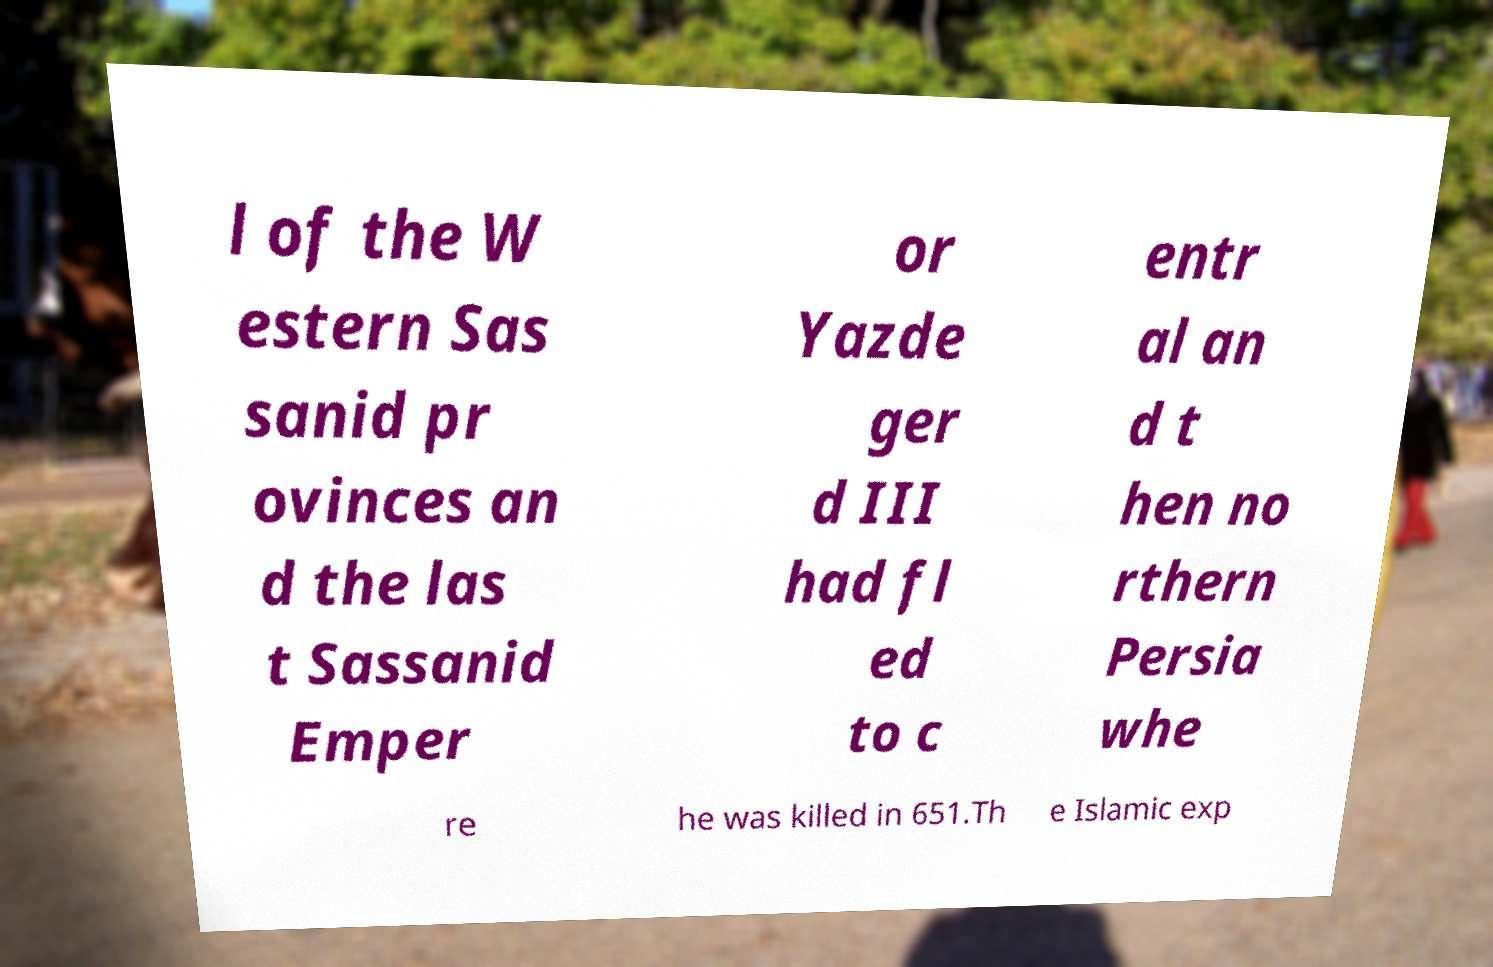What messages or text are displayed in this image? I need them in a readable, typed format. l of the W estern Sas sanid pr ovinces an d the las t Sassanid Emper or Yazde ger d III had fl ed to c entr al an d t hen no rthern Persia whe re he was killed in 651.Th e Islamic exp 